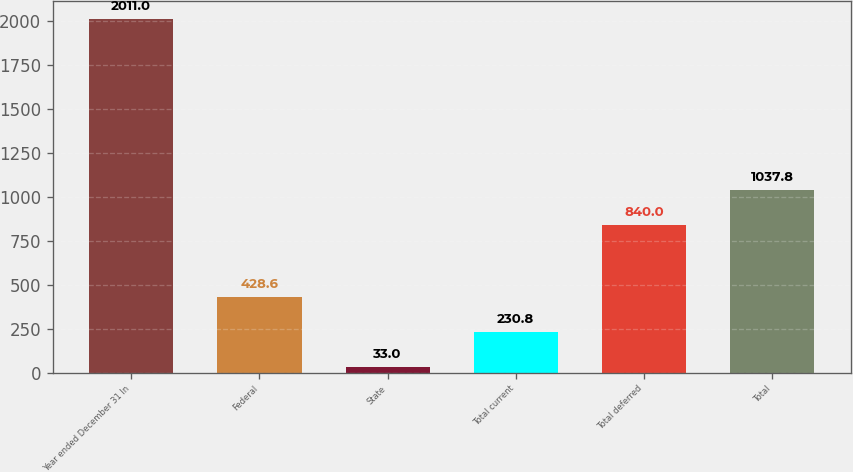Convert chart. <chart><loc_0><loc_0><loc_500><loc_500><bar_chart><fcel>Year ended December 31 In<fcel>Federal<fcel>State<fcel>Total current<fcel>Total deferred<fcel>Total<nl><fcel>2011<fcel>428.6<fcel>33<fcel>230.8<fcel>840<fcel>1037.8<nl></chart> 